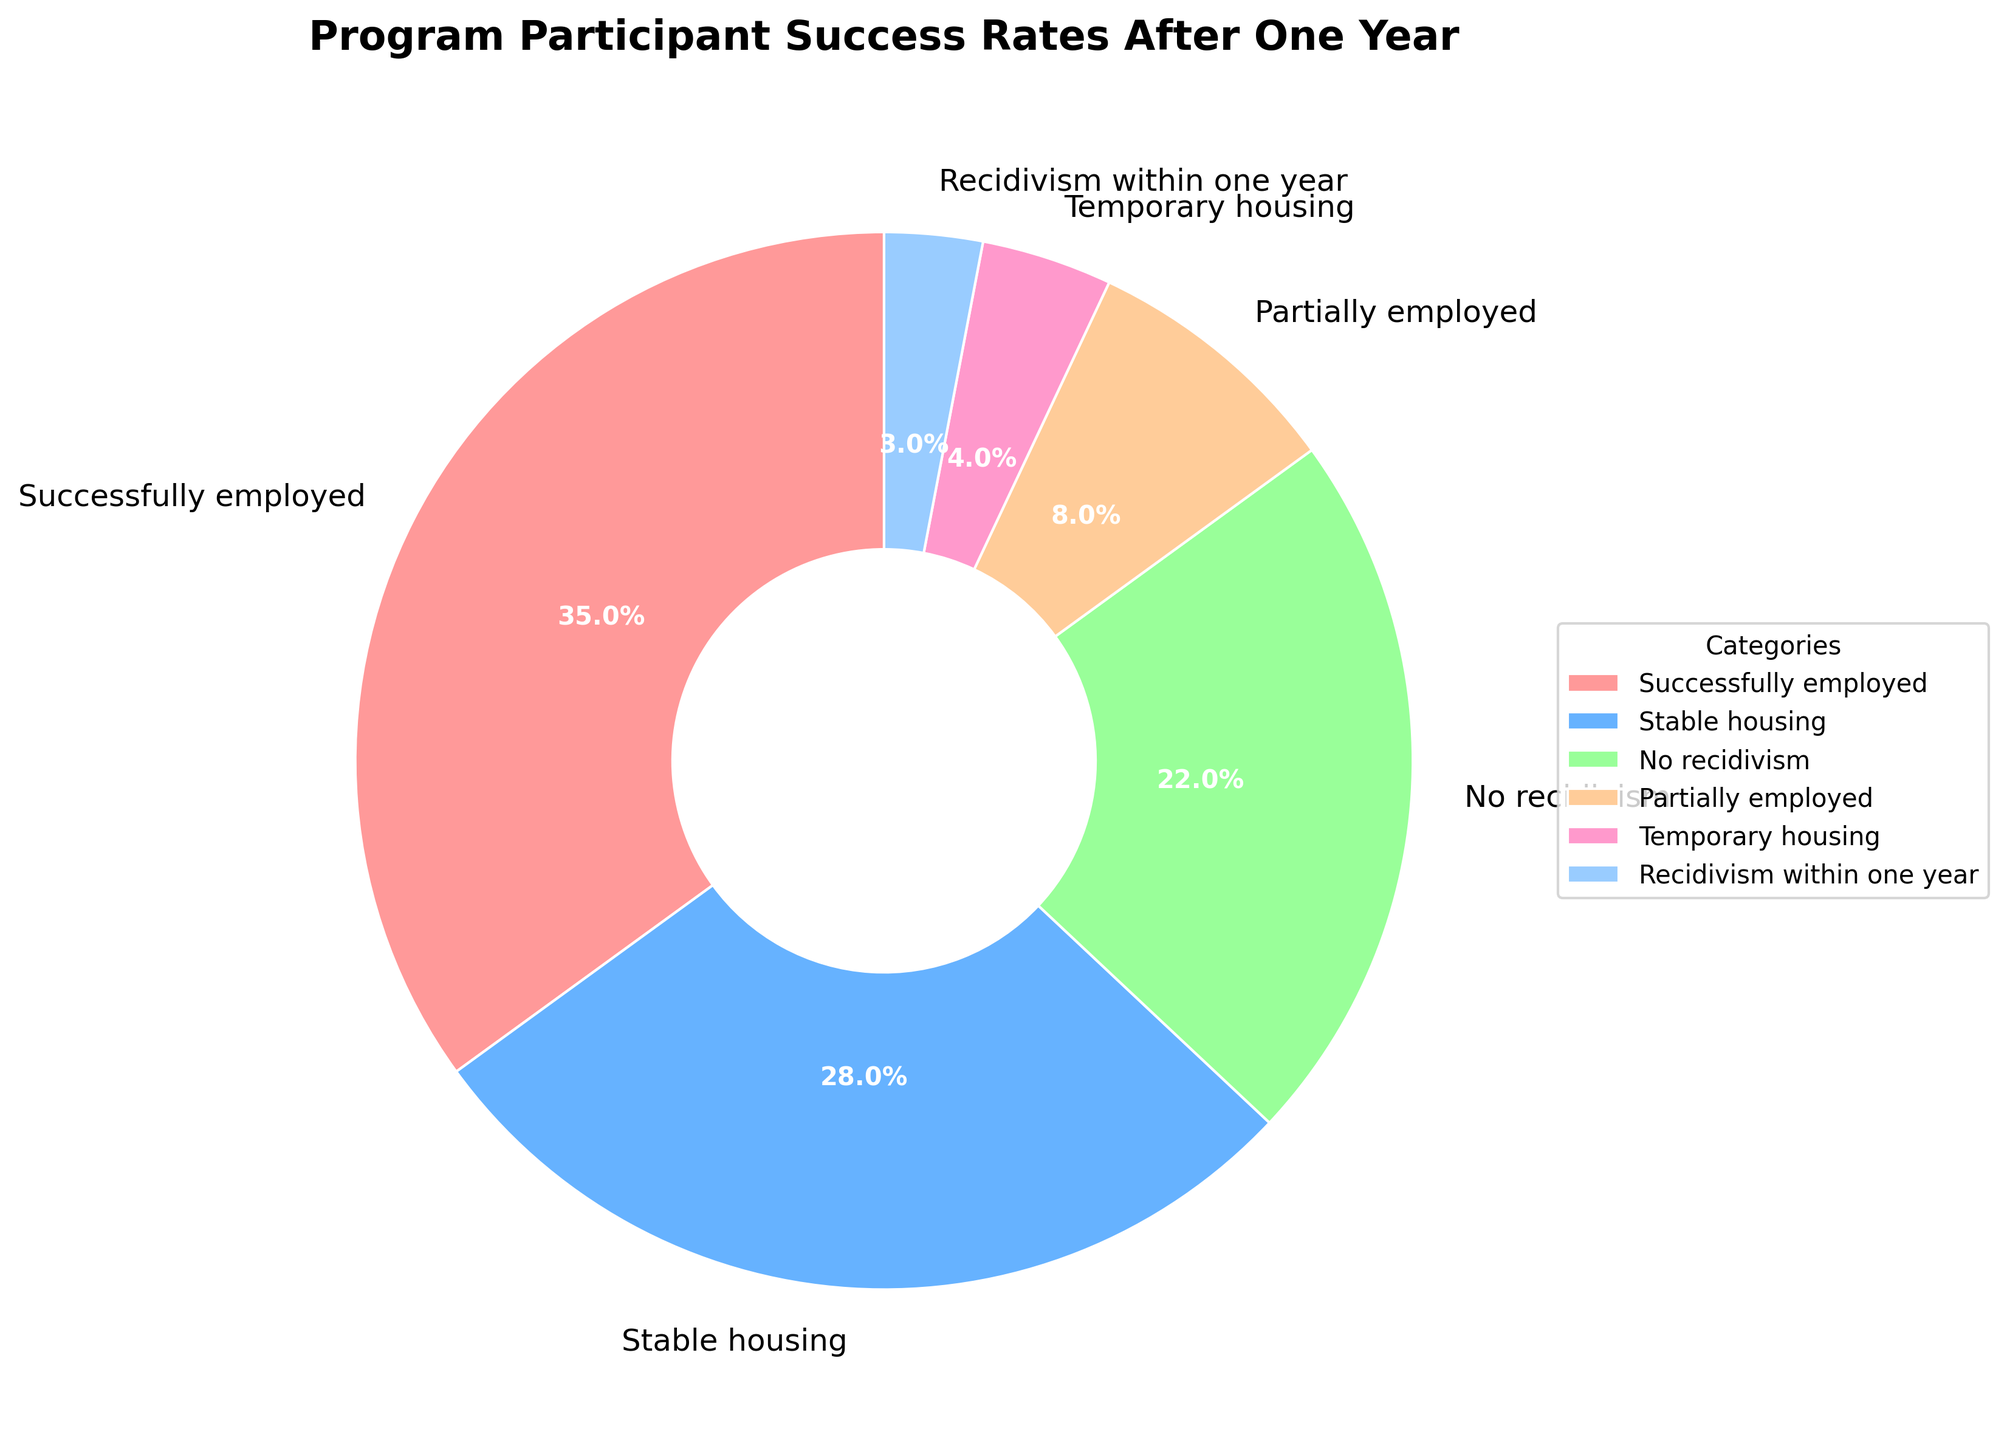What's the category with the highest success rate? Look at the segments in the pie chart and identify which one has the largest percentage. The "Successfully employed" category has the largest segment with 35%.
Answer: Successfully employed Which category has the smallest percentage? Identify the smallest segment in the pie chart by comparing their sizes. The "Recidivism within one year" category has the smallest segment at 3%.
Answer: Recidivism within one year What is the combined percentage of participants who were either successfully or partially employed? Sum the percentages of "Successfully employed" and "Partially employed". These are 35% and 8%, respectively. So, 35% + 8% = 43%.
Answer: 43% Are there more participants with stable housing or without recidivism within one year? Compare the percentages of "Stable housing" and "No recidivism". Stable housing has 28% while No recidivism has 22%. Thus, more participants have stable housing.
Answer: Stable housing What percentage of participants are in either temporary housing or had recidivism within one year? Sum the percentages of "Temporary housing" and "Recidivism within one year". These are 4% and 3%, respectively. So, 4% + 3% = 7%.
Answer: 7% Is the percentage of participants in temporary housing higher or lower than those partially employed? Compare the percentages of "Temporary housing" and "Partially employed". Temporary housing has 4% while Partially employed has 8%. Thus, Temporary housing is lower.
Answer: Lower Compare and find the difference between participants with stable housing and those successfully employed. Subtract the percentage of Stable housing from Successfully employed. That is 35% - 28% = 7%.
Answer: 7% Among the categories, which has more participants: No recidivism or Partially employed? Check the percentages for "No recidivism" and "Partially employed". No recidivism has 22%, and Partially employed has 8%. Therefore, No recidivism has more participants.
Answer: No recidivism Which category represents more than a quarter of the participants? Identify which category’s percentage is greater than 25%. "Successfully employed" at 35% and "Stable housing" at 28% both fit this criterion.
Answer: Successfully employed, Stable housing What is the sum of the three smallest categories? Add the percentages of "Partially employed", "Temporary housing", and "Recidivism within one year". These are 8%, 4%, and 3% respectively. So, 8% + 4% + 3% = 15%.
Answer: 15% 